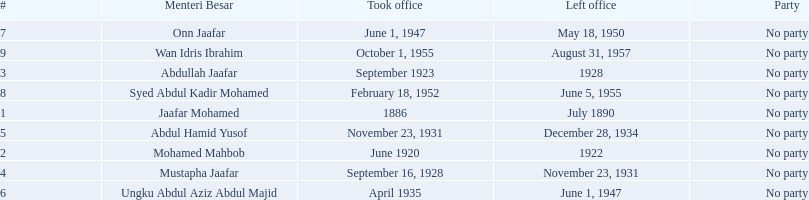Who was in office previous to abdullah jaafar? Mohamed Mahbob. 